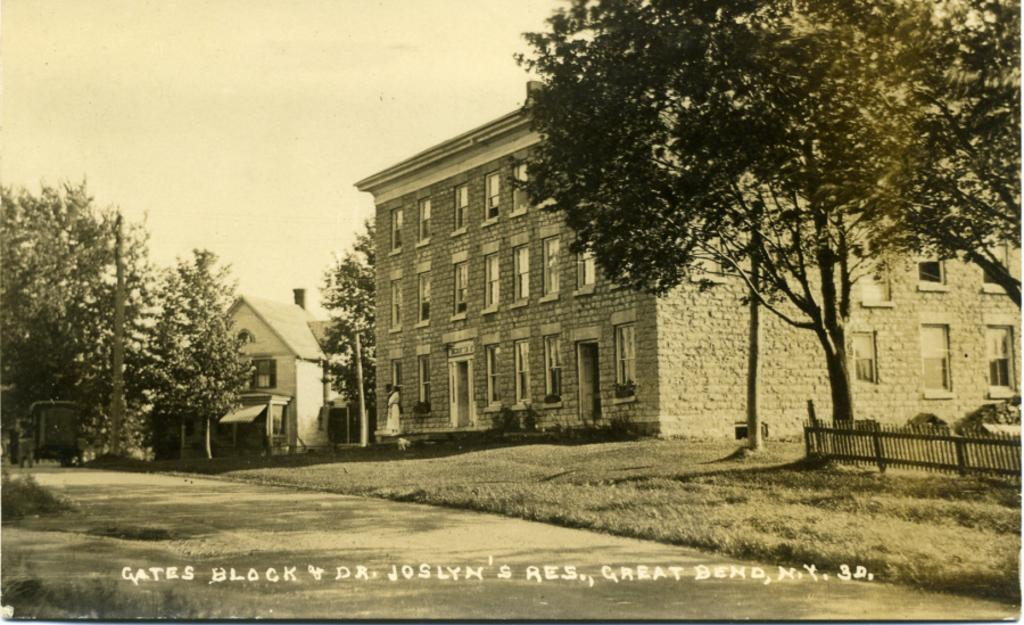What type of structures can be seen in the image? There are houses in the image. What architectural features are present on the houses? There are windows in the image. What other objects can be seen in the image? There are poles, plants, trees, and a fence in the image. What is visible in the background of the image? The sky is visible in the image. Is there any text present in the image? Yes, there is some text on the image. What is the price of the island shown in the image? There is no island present in the image, so it is not possible to determine its price. 